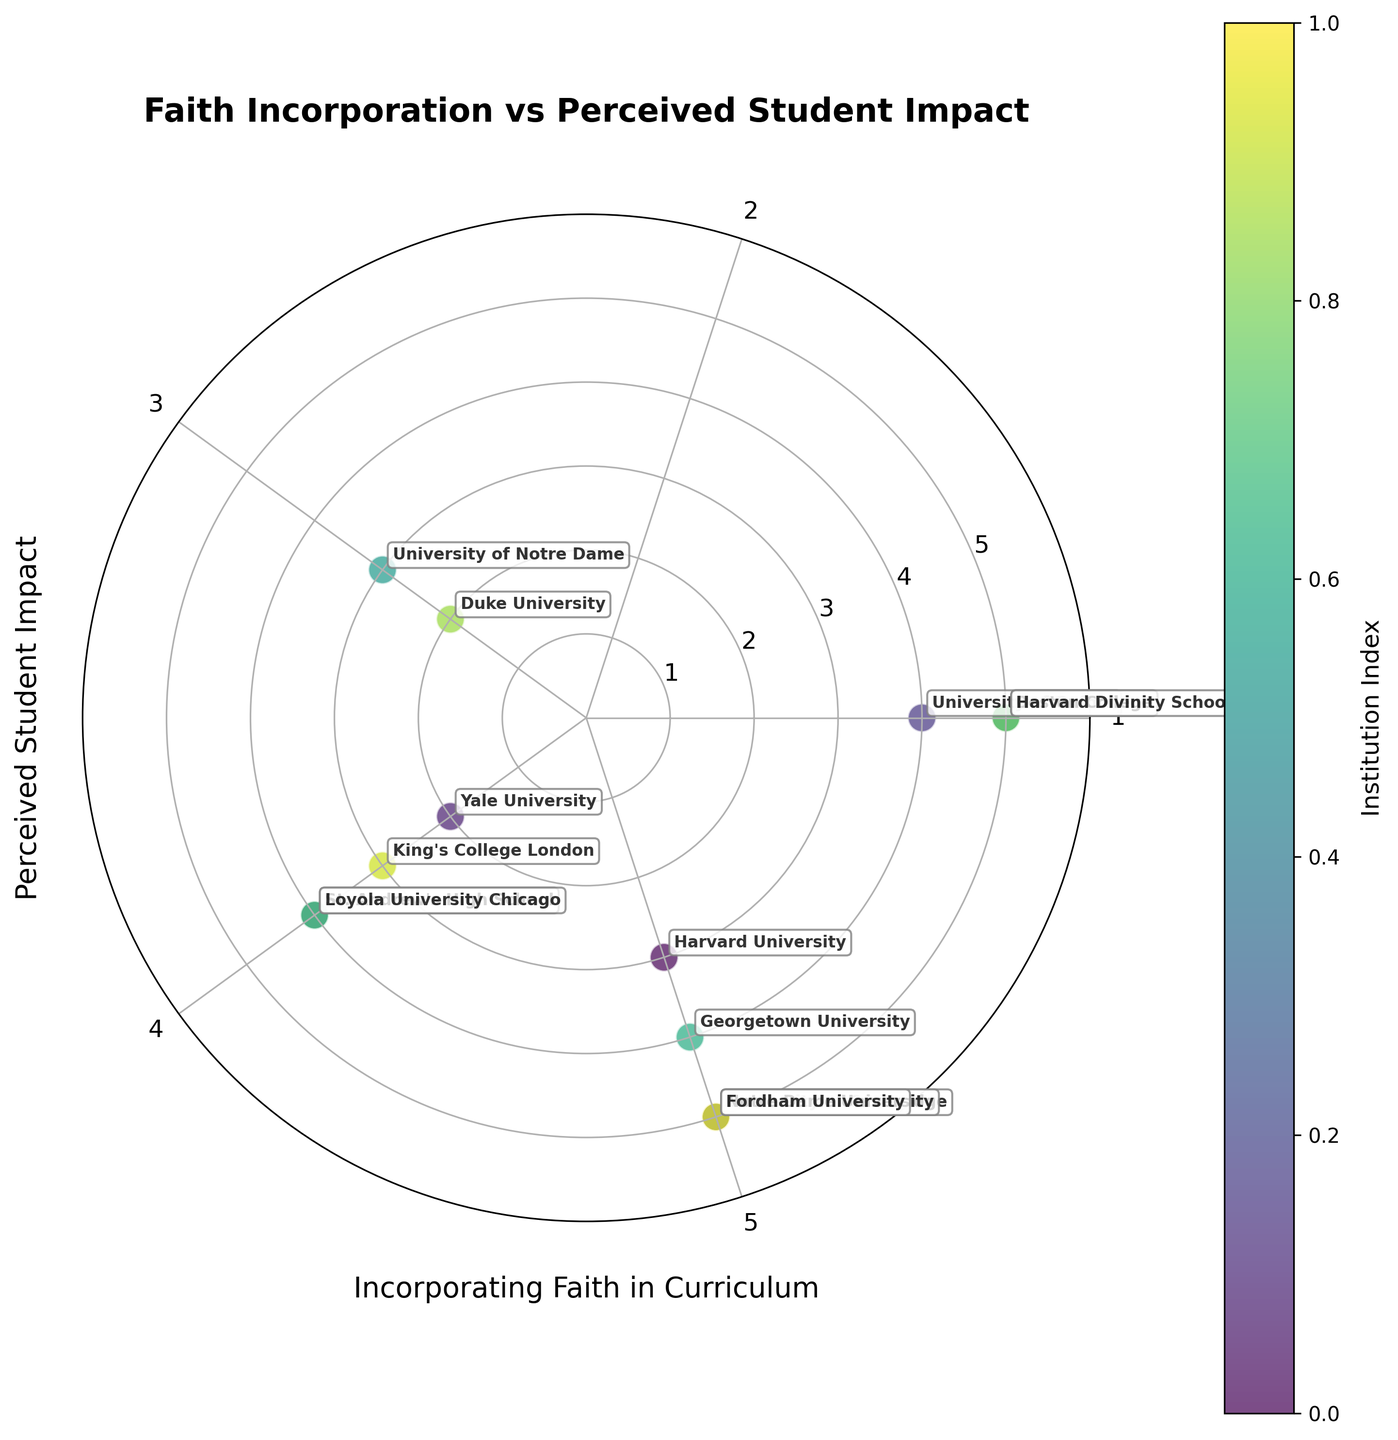What is the title of the figure? The title of the figure is usually found at the top of the chart. In this case, it is clearly labeled.
Answer: Faith Incorporation vs Perceived Student Impact How many data points are displayed on the chart? To determine the number of data points, we count each unique scatter point visible in the plot.
Answer: 14 Which institution shows the highest "Perceived Student Impact"? By looking for the point that is furthest from the center (the highest 'r' value), we can identify the institution. Based on the annotations, this corresponds to multiple institutions reaching a value of 5 on the radial axis.
Answer: Boston College, University of Cambridge, Harvard Divinity School, Fordham University, and Notre Dame University Which data point(s) have the lowest value for "Incorporating Faith in Curriculum"? To identify this, observe the position of the points closest to the radial angle corresponding to the value 2. Multiple institutions are represented here.
Answer: University of Notre Dame and Duke University What is the perceived student impact for the teachers from Harvard University and Yale University? Find the points labeled "Harvard University" and "Yale University" and check their radial distance from the center. This tells the perceived student impact.
Answer: Harvard University: 3, Yale University: 2 Are there any institutions with both "Incorporating Faith in Curriculum" and "Perceived Student Impact" at level 5? Check if any point lies at the radial distance of 5 and is along the angle corresponding to a value of 5 for "Incorporating Faith in Curriculum".
Answer: Yes, Harvard Divinity School and Boston College Which institution is placed closest to the origin of the plot? The closest point to the center has both the lowest values for "Incorporating Faith in Curriculum" and "Perceived Student Impact".
Answer: Duke University Count the institutions that rated "Incorporating Faith in Curriculum" as 4. Count the number of points that lie at the angle corresponding to the value 4 on the circle.
Answer: 5 institutions Compare the perceived student impact between the Lecturer roles at the University of Oxford and Duke University. Locate the points labeled "University of Oxford" and "Duke University" and check their radial distances.
Answer: University of Oxford: 4, Duke University: 2 Which institution has a greater perceived student impact from incorporating faith in the curriculum, Loyola University Chicago or St. Andrew's High School? Find the points labeled "Loyola University Chicago" and "St. Andrew's High School" and compare their radial distances from the center of the chart.
Answer: St. Andrew's High School 